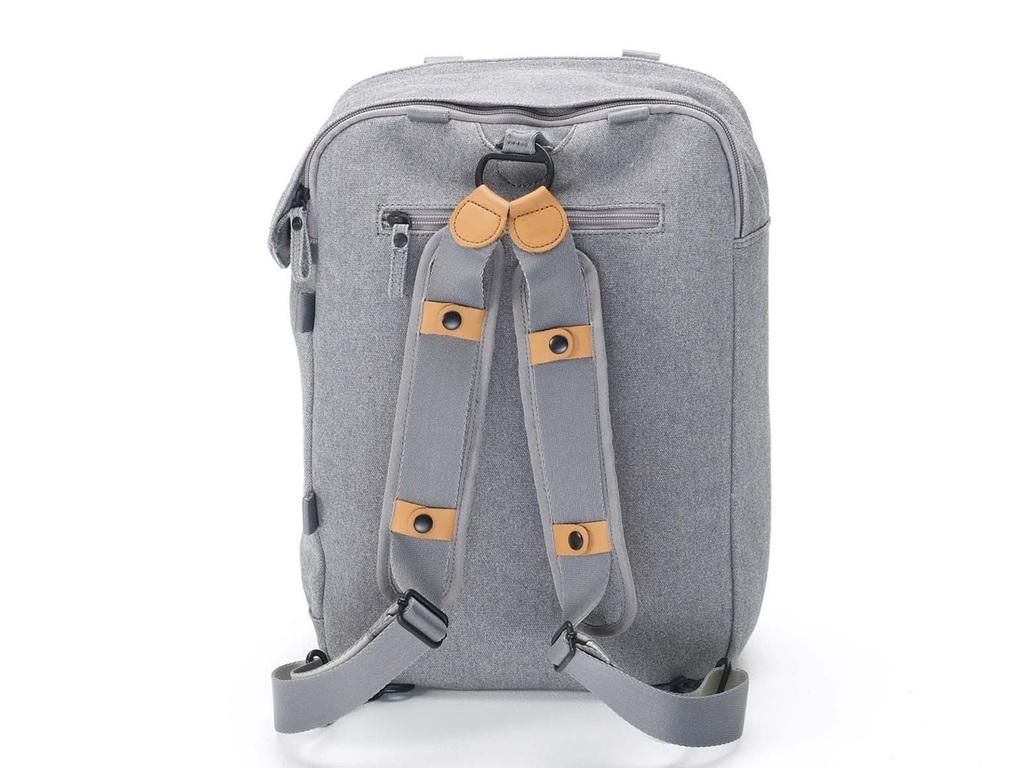Can you describe this image briefly? here in this picture we can see the bag. 